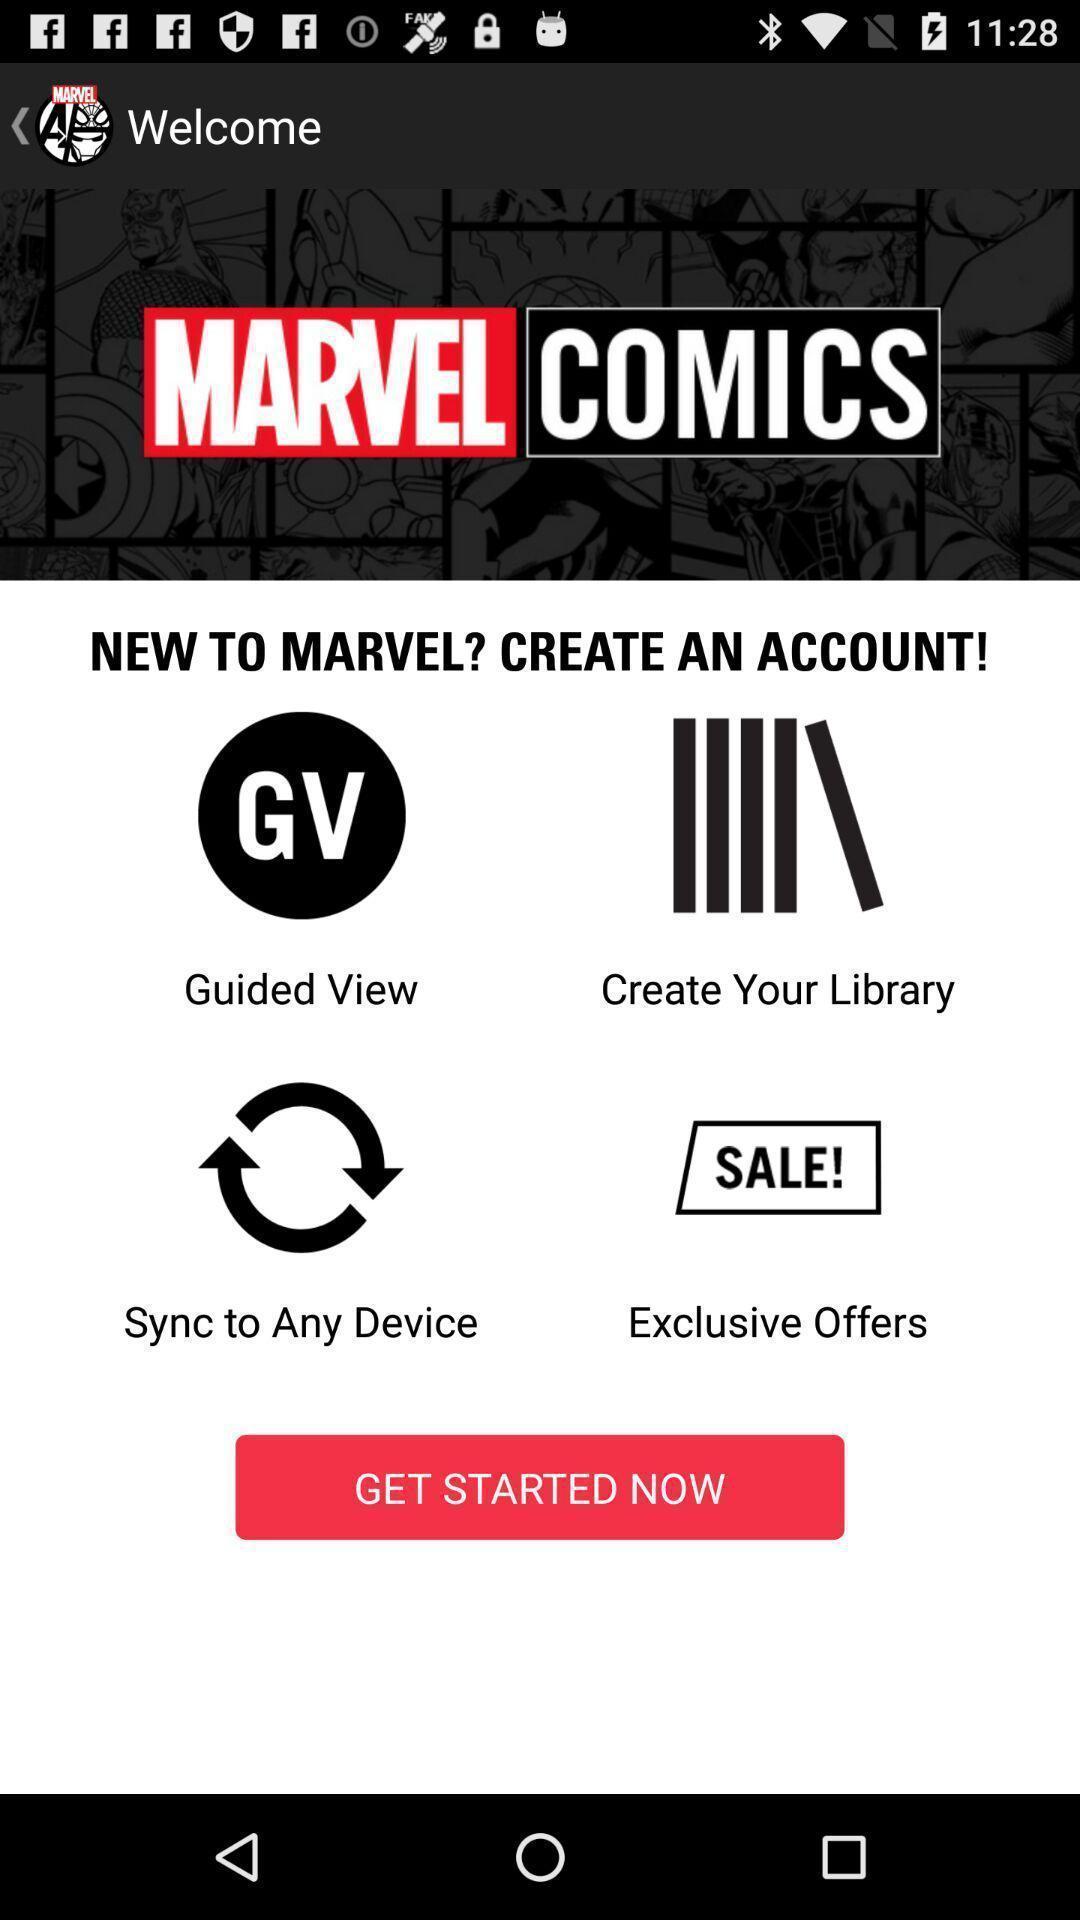Summarize the information in this screenshot. Welcome page. 